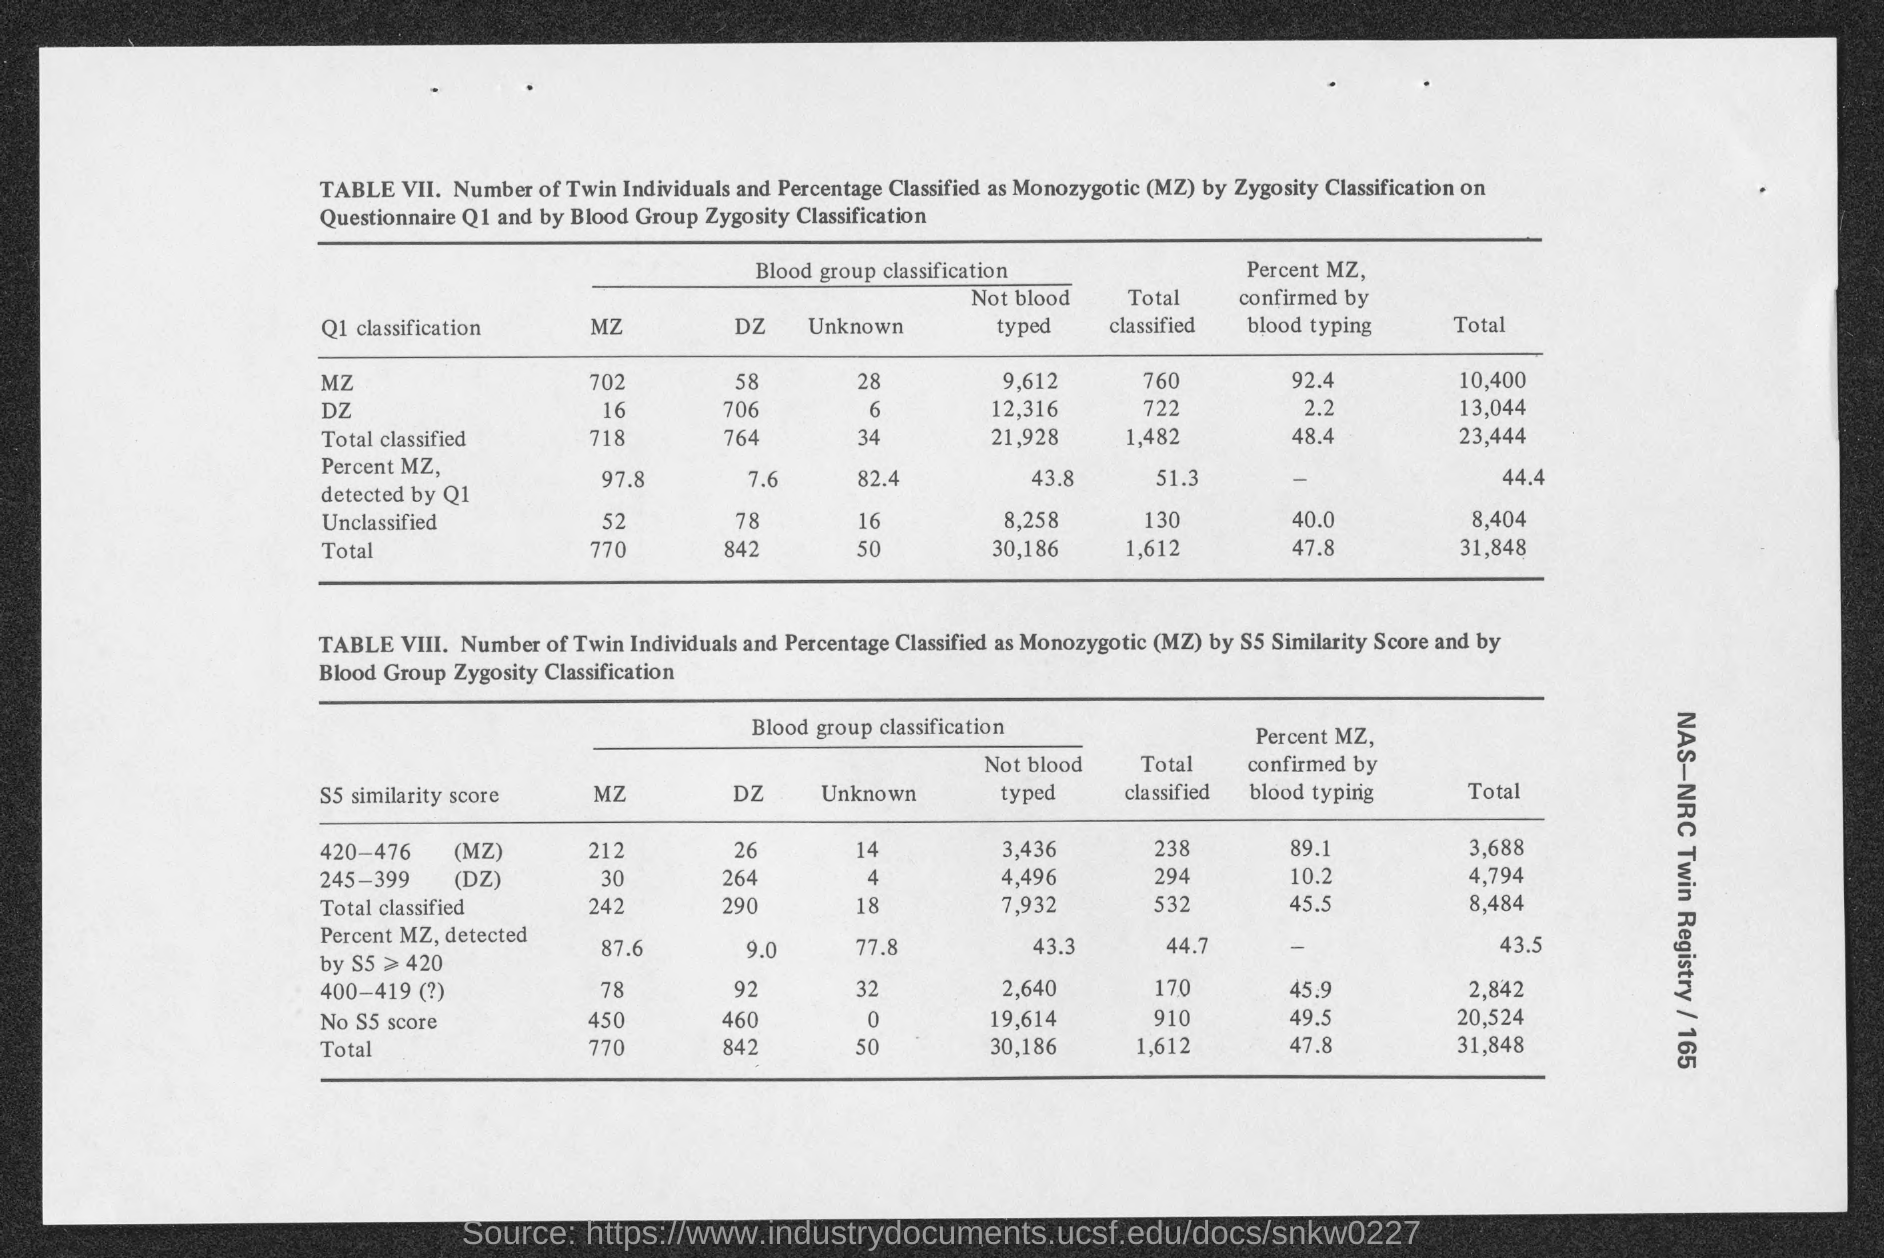What is "MZ" ?
Offer a very short reply. Monozygotic. What is first 'Q1 classification' on the Table VII ?
Provide a succinct answer. MZ. 